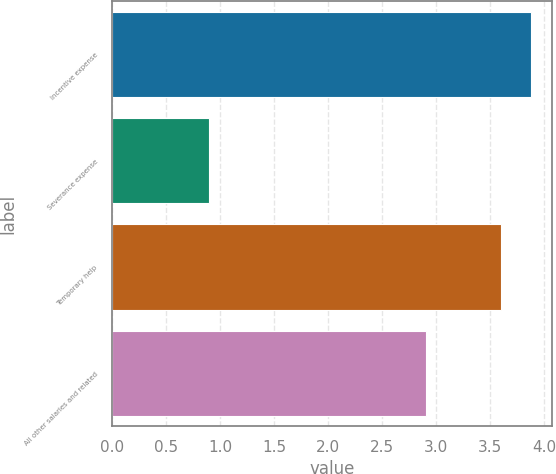Convert chart to OTSL. <chart><loc_0><loc_0><loc_500><loc_500><bar_chart><fcel>Incentive expense<fcel>Severance expense<fcel>Temporary help<fcel>All other salaries and related<nl><fcel>3.88<fcel>0.9<fcel>3.6<fcel>2.9<nl></chart> 